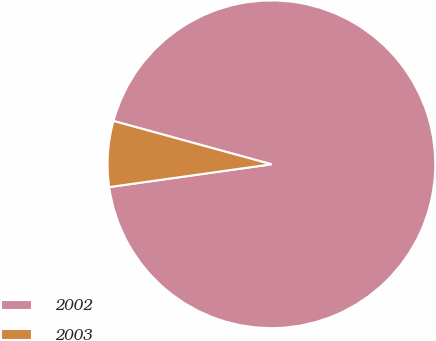Convert chart to OTSL. <chart><loc_0><loc_0><loc_500><loc_500><pie_chart><fcel>2002<fcel>2003<nl><fcel>93.52%<fcel>6.48%<nl></chart> 